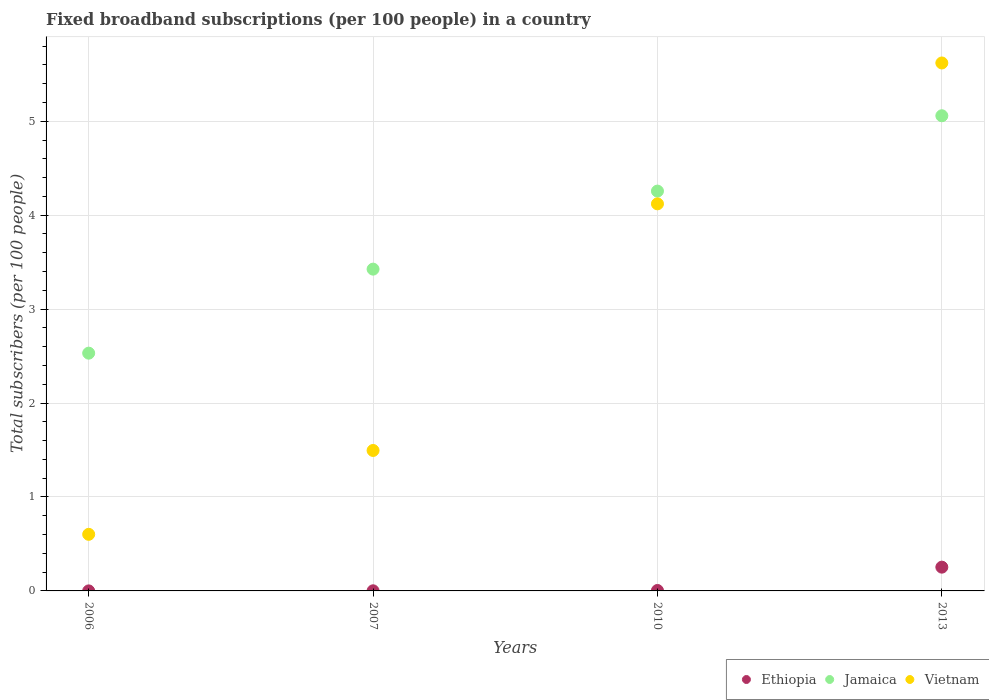Is the number of dotlines equal to the number of legend labels?
Your answer should be compact. Yes. What is the number of broadband subscriptions in Ethiopia in 2007?
Give a very brief answer. 0. Across all years, what is the maximum number of broadband subscriptions in Jamaica?
Make the answer very short. 5.06. Across all years, what is the minimum number of broadband subscriptions in Jamaica?
Offer a terse response. 2.53. In which year was the number of broadband subscriptions in Vietnam minimum?
Ensure brevity in your answer.  2006. What is the total number of broadband subscriptions in Ethiopia in the graph?
Offer a terse response. 0.26. What is the difference between the number of broadband subscriptions in Vietnam in 2007 and that in 2013?
Your response must be concise. -4.13. What is the difference between the number of broadband subscriptions in Vietnam in 2013 and the number of broadband subscriptions in Ethiopia in 2010?
Your answer should be compact. 5.62. What is the average number of broadband subscriptions in Jamaica per year?
Keep it short and to the point. 3.82. In the year 2006, what is the difference between the number of broadband subscriptions in Ethiopia and number of broadband subscriptions in Jamaica?
Provide a short and direct response. -2.53. What is the ratio of the number of broadband subscriptions in Jamaica in 2006 to that in 2013?
Provide a short and direct response. 0.5. Is the difference between the number of broadband subscriptions in Ethiopia in 2010 and 2013 greater than the difference between the number of broadband subscriptions in Jamaica in 2010 and 2013?
Provide a succinct answer. Yes. What is the difference between the highest and the second highest number of broadband subscriptions in Vietnam?
Provide a short and direct response. 1.5. What is the difference between the highest and the lowest number of broadband subscriptions in Ethiopia?
Ensure brevity in your answer.  0.25. Is it the case that in every year, the sum of the number of broadband subscriptions in Vietnam and number of broadband subscriptions in Ethiopia  is greater than the number of broadband subscriptions in Jamaica?
Keep it short and to the point. No. Is the number of broadband subscriptions in Ethiopia strictly less than the number of broadband subscriptions in Vietnam over the years?
Offer a terse response. Yes. How many years are there in the graph?
Your response must be concise. 4. What is the difference between two consecutive major ticks on the Y-axis?
Your response must be concise. 1. Are the values on the major ticks of Y-axis written in scientific E-notation?
Ensure brevity in your answer.  No. Does the graph contain any zero values?
Your response must be concise. No. Where does the legend appear in the graph?
Make the answer very short. Bottom right. What is the title of the graph?
Your answer should be compact. Fixed broadband subscriptions (per 100 people) in a country. Does "United Arab Emirates" appear as one of the legend labels in the graph?
Keep it short and to the point. No. What is the label or title of the Y-axis?
Your response must be concise. Total subscribers (per 100 people). What is the Total subscribers (per 100 people) in Ethiopia in 2006?
Provide a short and direct response. 0. What is the Total subscribers (per 100 people) of Jamaica in 2006?
Give a very brief answer. 2.53. What is the Total subscribers (per 100 people) of Vietnam in 2006?
Provide a succinct answer. 0.6. What is the Total subscribers (per 100 people) of Ethiopia in 2007?
Give a very brief answer. 0. What is the Total subscribers (per 100 people) of Jamaica in 2007?
Give a very brief answer. 3.43. What is the Total subscribers (per 100 people) in Vietnam in 2007?
Offer a terse response. 1.5. What is the Total subscribers (per 100 people) of Ethiopia in 2010?
Provide a succinct answer. 0. What is the Total subscribers (per 100 people) of Jamaica in 2010?
Offer a terse response. 4.26. What is the Total subscribers (per 100 people) in Vietnam in 2010?
Give a very brief answer. 4.12. What is the Total subscribers (per 100 people) of Ethiopia in 2013?
Provide a succinct answer. 0.25. What is the Total subscribers (per 100 people) in Jamaica in 2013?
Your answer should be very brief. 5.06. What is the Total subscribers (per 100 people) in Vietnam in 2013?
Ensure brevity in your answer.  5.62. Across all years, what is the maximum Total subscribers (per 100 people) of Ethiopia?
Ensure brevity in your answer.  0.25. Across all years, what is the maximum Total subscribers (per 100 people) in Jamaica?
Your answer should be compact. 5.06. Across all years, what is the maximum Total subscribers (per 100 people) in Vietnam?
Offer a very short reply. 5.62. Across all years, what is the minimum Total subscribers (per 100 people) of Ethiopia?
Provide a short and direct response. 0. Across all years, what is the minimum Total subscribers (per 100 people) in Jamaica?
Give a very brief answer. 2.53. Across all years, what is the minimum Total subscribers (per 100 people) in Vietnam?
Your answer should be compact. 0.6. What is the total Total subscribers (per 100 people) in Ethiopia in the graph?
Provide a succinct answer. 0.26. What is the total Total subscribers (per 100 people) of Jamaica in the graph?
Give a very brief answer. 15.27. What is the total Total subscribers (per 100 people) of Vietnam in the graph?
Give a very brief answer. 11.84. What is the difference between the Total subscribers (per 100 people) of Ethiopia in 2006 and that in 2007?
Give a very brief answer. -0. What is the difference between the Total subscribers (per 100 people) in Jamaica in 2006 and that in 2007?
Ensure brevity in your answer.  -0.89. What is the difference between the Total subscribers (per 100 people) in Vietnam in 2006 and that in 2007?
Keep it short and to the point. -0.89. What is the difference between the Total subscribers (per 100 people) of Ethiopia in 2006 and that in 2010?
Give a very brief answer. -0. What is the difference between the Total subscribers (per 100 people) of Jamaica in 2006 and that in 2010?
Keep it short and to the point. -1.73. What is the difference between the Total subscribers (per 100 people) in Vietnam in 2006 and that in 2010?
Ensure brevity in your answer.  -3.52. What is the difference between the Total subscribers (per 100 people) of Ethiopia in 2006 and that in 2013?
Offer a terse response. -0.25. What is the difference between the Total subscribers (per 100 people) in Jamaica in 2006 and that in 2013?
Offer a terse response. -2.53. What is the difference between the Total subscribers (per 100 people) of Vietnam in 2006 and that in 2013?
Provide a succinct answer. -5.02. What is the difference between the Total subscribers (per 100 people) of Ethiopia in 2007 and that in 2010?
Provide a succinct answer. -0. What is the difference between the Total subscribers (per 100 people) in Jamaica in 2007 and that in 2010?
Your answer should be compact. -0.83. What is the difference between the Total subscribers (per 100 people) in Vietnam in 2007 and that in 2010?
Provide a succinct answer. -2.63. What is the difference between the Total subscribers (per 100 people) in Ethiopia in 2007 and that in 2013?
Offer a very short reply. -0.25. What is the difference between the Total subscribers (per 100 people) in Jamaica in 2007 and that in 2013?
Give a very brief answer. -1.63. What is the difference between the Total subscribers (per 100 people) of Vietnam in 2007 and that in 2013?
Keep it short and to the point. -4.12. What is the difference between the Total subscribers (per 100 people) of Ethiopia in 2010 and that in 2013?
Offer a terse response. -0.25. What is the difference between the Total subscribers (per 100 people) in Jamaica in 2010 and that in 2013?
Your answer should be compact. -0.8. What is the difference between the Total subscribers (per 100 people) in Vietnam in 2010 and that in 2013?
Keep it short and to the point. -1.5. What is the difference between the Total subscribers (per 100 people) in Ethiopia in 2006 and the Total subscribers (per 100 people) in Jamaica in 2007?
Your answer should be very brief. -3.43. What is the difference between the Total subscribers (per 100 people) of Ethiopia in 2006 and the Total subscribers (per 100 people) of Vietnam in 2007?
Make the answer very short. -1.49. What is the difference between the Total subscribers (per 100 people) of Jamaica in 2006 and the Total subscribers (per 100 people) of Vietnam in 2007?
Provide a short and direct response. 1.04. What is the difference between the Total subscribers (per 100 people) in Ethiopia in 2006 and the Total subscribers (per 100 people) in Jamaica in 2010?
Provide a short and direct response. -4.26. What is the difference between the Total subscribers (per 100 people) of Ethiopia in 2006 and the Total subscribers (per 100 people) of Vietnam in 2010?
Offer a terse response. -4.12. What is the difference between the Total subscribers (per 100 people) of Jamaica in 2006 and the Total subscribers (per 100 people) of Vietnam in 2010?
Your answer should be compact. -1.59. What is the difference between the Total subscribers (per 100 people) of Ethiopia in 2006 and the Total subscribers (per 100 people) of Jamaica in 2013?
Provide a succinct answer. -5.06. What is the difference between the Total subscribers (per 100 people) in Ethiopia in 2006 and the Total subscribers (per 100 people) in Vietnam in 2013?
Provide a short and direct response. -5.62. What is the difference between the Total subscribers (per 100 people) in Jamaica in 2006 and the Total subscribers (per 100 people) in Vietnam in 2013?
Make the answer very short. -3.09. What is the difference between the Total subscribers (per 100 people) of Ethiopia in 2007 and the Total subscribers (per 100 people) of Jamaica in 2010?
Ensure brevity in your answer.  -4.25. What is the difference between the Total subscribers (per 100 people) of Ethiopia in 2007 and the Total subscribers (per 100 people) of Vietnam in 2010?
Give a very brief answer. -4.12. What is the difference between the Total subscribers (per 100 people) in Jamaica in 2007 and the Total subscribers (per 100 people) in Vietnam in 2010?
Offer a very short reply. -0.7. What is the difference between the Total subscribers (per 100 people) in Ethiopia in 2007 and the Total subscribers (per 100 people) in Jamaica in 2013?
Offer a very short reply. -5.06. What is the difference between the Total subscribers (per 100 people) in Ethiopia in 2007 and the Total subscribers (per 100 people) in Vietnam in 2013?
Offer a very short reply. -5.62. What is the difference between the Total subscribers (per 100 people) in Jamaica in 2007 and the Total subscribers (per 100 people) in Vietnam in 2013?
Provide a short and direct response. -2.19. What is the difference between the Total subscribers (per 100 people) in Ethiopia in 2010 and the Total subscribers (per 100 people) in Jamaica in 2013?
Your answer should be very brief. -5.05. What is the difference between the Total subscribers (per 100 people) in Ethiopia in 2010 and the Total subscribers (per 100 people) in Vietnam in 2013?
Give a very brief answer. -5.62. What is the difference between the Total subscribers (per 100 people) of Jamaica in 2010 and the Total subscribers (per 100 people) of Vietnam in 2013?
Your answer should be very brief. -1.36. What is the average Total subscribers (per 100 people) in Ethiopia per year?
Keep it short and to the point. 0.06. What is the average Total subscribers (per 100 people) of Jamaica per year?
Offer a terse response. 3.82. What is the average Total subscribers (per 100 people) in Vietnam per year?
Provide a succinct answer. 2.96. In the year 2006, what is the difference between the Total subscribers (per 100 people) of Ethiopia and Total subscribers (per 100 people) of Jamaica?
Provide a succinct answer. -2.53. In the year 2006, what is the difference between the Total subscribers (per 100 people) of Ethiopia and Total subscribers (per 100 people) of Vietnam?
Give a very brief answer. -0.6. In the year 2006, what is the difference between the Total subscribers (per 100 people) of Jamaica and Total subscribers (per 100 people) of Vietnam?
Ensure brevity in your answer.  1.93. In the year 2007, what is the difference between the Total subscribers (per 100 people) in Ethiopia and Total subscribers (per 100 people) in Jamaica?
Give a very brief answer. -3.42. In the year 2007, what is the difference between the Total subscribers (per 100 people) in Ethiopia and Total subscribers (per 100 people) in Vietnam?
Ensure brevity in your answer.  -1.49. In the year 2007, what is the difference between the Total subscribers (per 100 people) in Jamaica and Total subscribers (per 100 people) in Vietnam?
Make the answer very short. 1.93. In the year 2010, what is the difference between the Total subscribers (per 100 people) in Ethiopia and Total subscribers (per 100 people) in Jamaica?
Your response must be concise. -4.25. In the year 2010, what is the difference between the Total subscribers (per 100 people) of Ethiopia and Total subscribers (per 100 people) of Vietnam?
Your response must be concise. -4.12. In the year 2010, what is the difference between the Total subscribers (per 100 people) of Jamaica and Total subscribers (per 100 people) of Vietnam?
Keep it short and to the point. 0.14. In the year 2013, what is the difference between the Total subscribers (per 100 people) in Ethiopia and Total subscribers (per 100 people) in Jamaica?
Provide a succinct answer. -4.81. In the year 2013, what is the difference between the Total subscribers (per 100 people) of Ethiopia and Total subscribers (per 100 people) of Vietnam?
Offer a terse response. -5.37. In the year 2013, what is the difference between the Total subscribers (per 100 people) in Jamaica and Total subscribers (per 100 people) in Vietnam?
Ensure brevity in your answer.  -0.56. What is the ratio of the Total subscribers (per 100 people) in Ethiopia in 2006 to that in 2007?
Make the answer very short. 0.26. What is the ratio of the Total subscribers (per 100 people) in Jamaica in 2006 to that in 2007?
Your response must be concise. 0.74. What is the ratio of the Total subscribers (per 100 people) in Vietnam in 2006 to that in 2007?
Provide a succinct answer. 0.4. What is the ratio of the Total subscribers (per 100 people) of Ethiopia in 2006 to that in 2010?
Offer a very short reply. 0.07. What is the ratio of the Total subscribers (per 100 people) in Jamaica in 2006 to that in 2010?
Keep it short and to the point. 0.59. What is the ratio of the Total subscribers (per 100 people) of Vietnam in 2006 to that in 2010?
Your answer should be very brief. 0.15. What is the ratio of the Total subscribers (per 100 people) of Ethiopia in 2006 to that in 2013?
Your answer should be very brief. 0. What is the ratio of the Total subscribers (per 100 people) in Jamaica in 2006 to that in 2013?
Give a very brief answer. 0.5. What is the ratio of the Total subscribers (per 100 people) in Vietnam in 2006 to that in 2013?
Offer a very short reply. 0.11. What is the ratio of the Total subscribers (per 100 people) in Ethiopia in 2007 to that in 2010?
Ensure brevity in your answer.  0.27. What is the ratio of the Total subscribers (per 100 people) in Jamaica in 2007 to that in 2010?
Offer a very short reply. 0.8. What is the ratio of the Total subscribers (per 100 people) in Vietnam in 2007 to that in 2010?
Make the answer very short. 0.36. What is the ratio of the Total subscribers (per 100 people) in Ethiopia in 2007 to that in 2013?
Your answer should be very brief. 0.01. What is the ratio of the Total subscribers (per 100 people) of Jamaica in 2007 to that in 2013?
Your response must be concise. 0.68. What is the ratio of the Total subscribers (per 100 people) of Vietnam in 2007 to that in 2013?
Provide a short and direct response. 0.27. What is the ratio of the Total subscribers (per 100 people) of Ethiopia in 2010 to that in 2013?
Keep it short and to the point. 0.02. What is the ratio of the Total subscribers (per 100 people) of Jamaica in 2010 to that in 2013?
Provide a succinct answer. 0.84. What is the ratio of the Total subscribers (per 100 people) of Vietnam in 2010 to that in 2013?
Your response must be concise. 0.73. What is the difference between the highest and the second highest Total subscribers (per 100 people) of Ethiopia?
Ensure brevity in your answer.  0.25. What is the difference between the highest and the second highest Total subscribers (per 100 people) in Jamaica?
Your answer should be compact. 0.8. What is the difference between the highest and the second highest Total subscribers (per 100 people) of Vietnam?
Your answer should be very brief. 1.5. What is the difference between the highest and the lowest Total subscribers (per 100 people) in Ethiopia?
Ensure brevity in your answer.  0.25. What is the difference between the highest and the lowest Total subscribers (per 100 people) of Jamaica?
Give a very brief answer. 2.53. What is the difference between the highest and the lowest Total subscribers (per 100 people) of Vietnam?
Your answer should be very brief. 5.02. 